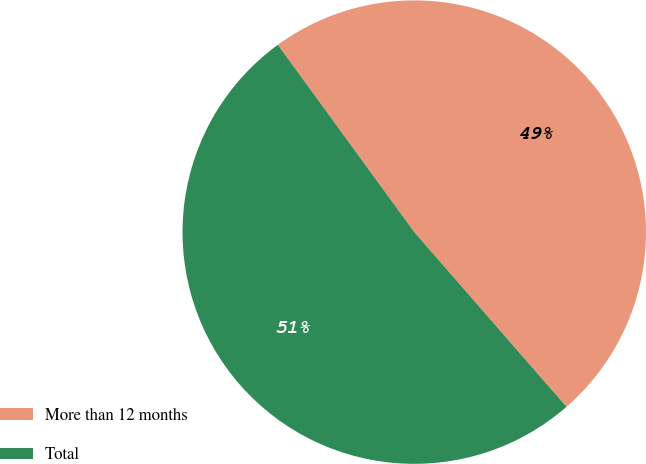Convert chart. <chart><loc_0><loc_0><loc_500><loc_500><pie_chart><fcel>More than 12 months<fcel>Total<nl><fcel>48.61%<fcel>51.39%<nl></chart> 